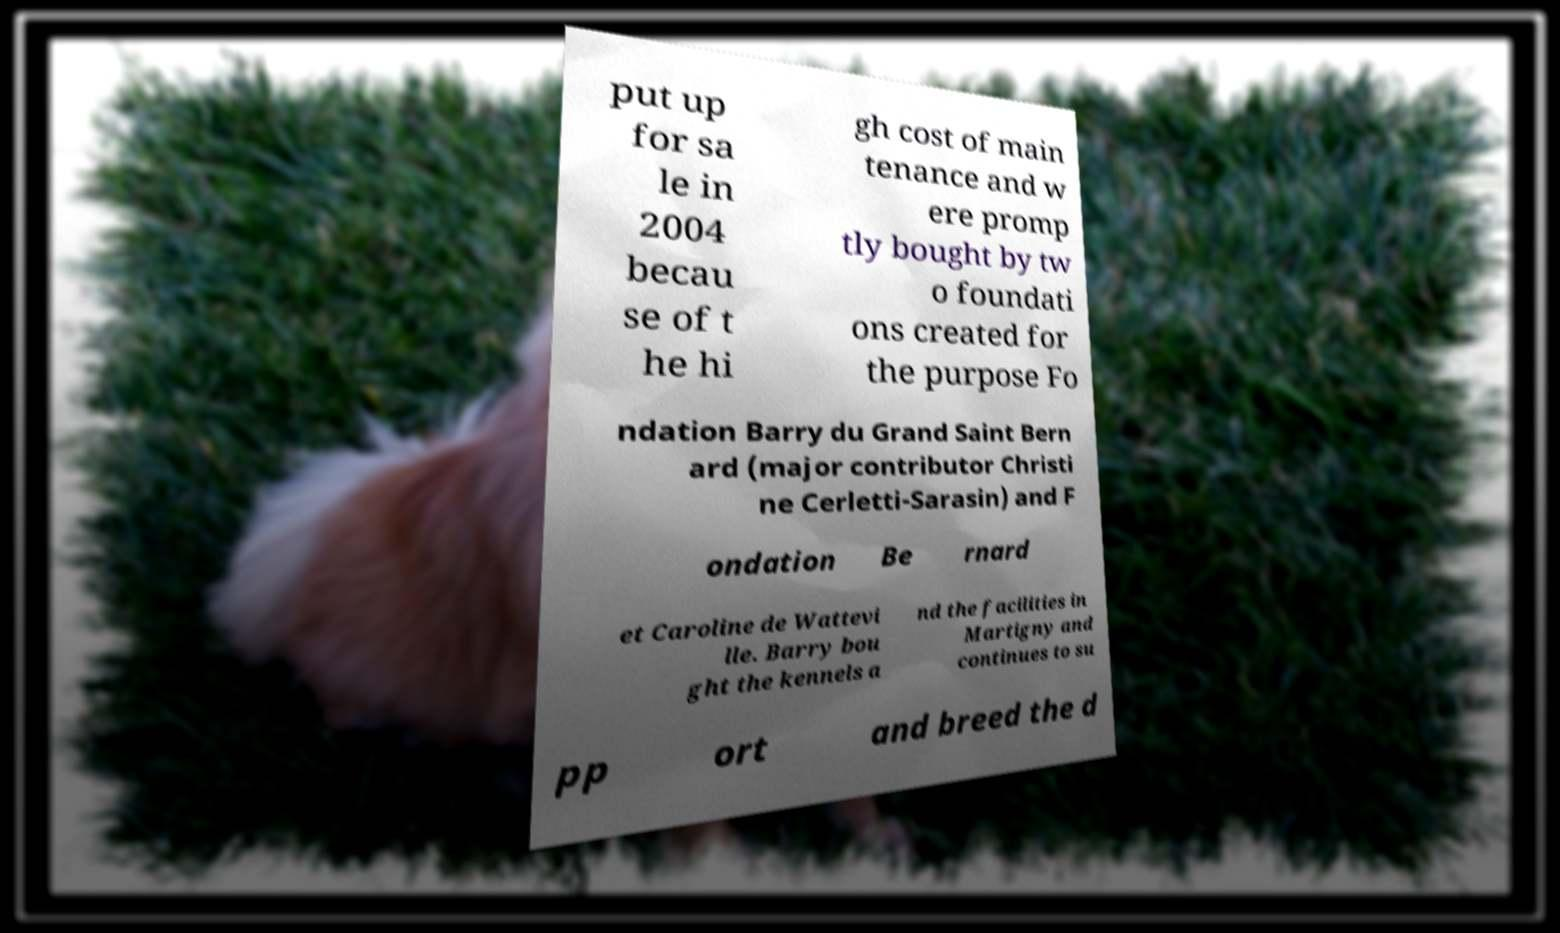Can you read and provide the text displayed in the image?This photo seems to have some interesting text. Can you extract and type it out for me? put up for sa le in 2004 becau se of t he hi gh cost of main tenance and w ere promp tly bought by tw o foundati ons created for the purpose Fo ndation Barry du Grand Saint Bern ard (major contributor Christi ne Cerletti-Sarasin) and F ondation Be rnard et Caroline de Wattevi lle. Barry bou ght the kennels a nd the facilities in Martigny and continues to su pp ort and breed the d 